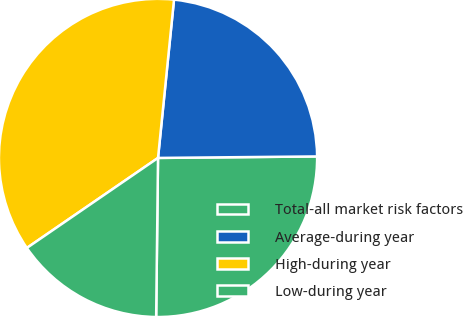Convert chart. <chart><loc_0><loc_0><loc_500><loc_500><pie_chart><fcel>Total-all market risk factors<fcel>Average-during year<fcel>High-during year<fcel>Low-during year<nl><fcel>25.34%<fcel>23.25%<fcel>36.18%<fcel>15.24%<nl></chart> 